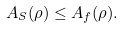Convert formula to latex. <formula><loc_0><loc_0><loc_500><loc_500>A _ { S } ( \rho ) \leq A _ { f } ( \rho ) .</formula> 